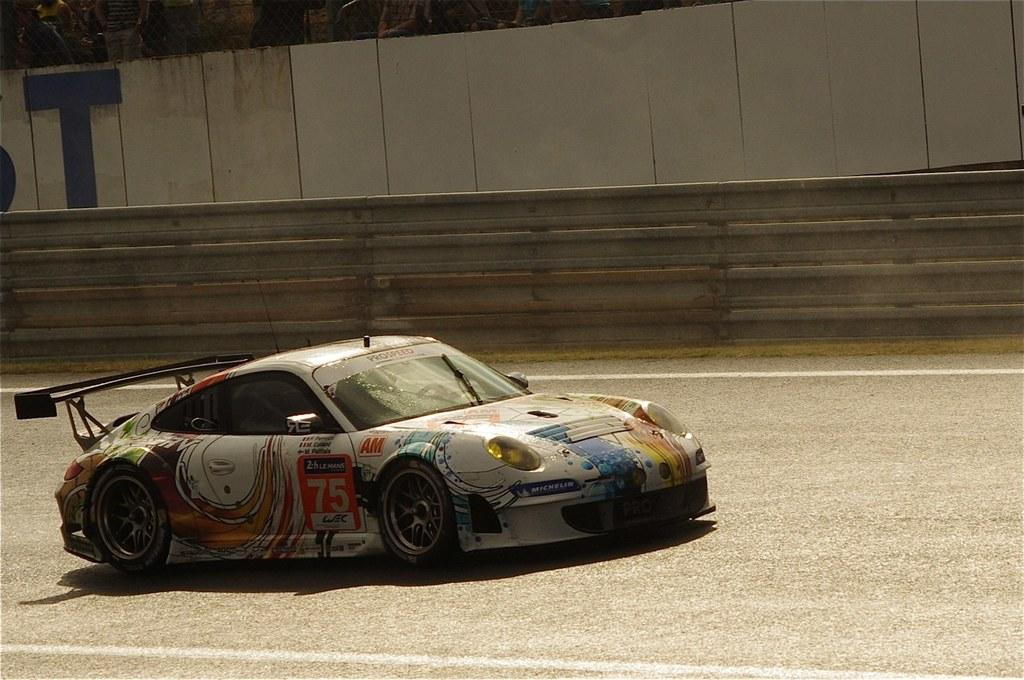What is the main subject in the foreground of the image? There is a car in the foreground of the image. What is the setting of the image? There is a road in the image. What can be seen in the background of the image? There is a wall in the background of the image. Who might be observing the scene in the image? There are audience members visible at the top of the image. What type of mask is the car wearing in the image? There is no mask present in the image, as cars do not wear masks. How many legs can be seen supporting the car in the image? Cars do not have legs; they have wheels for support. 